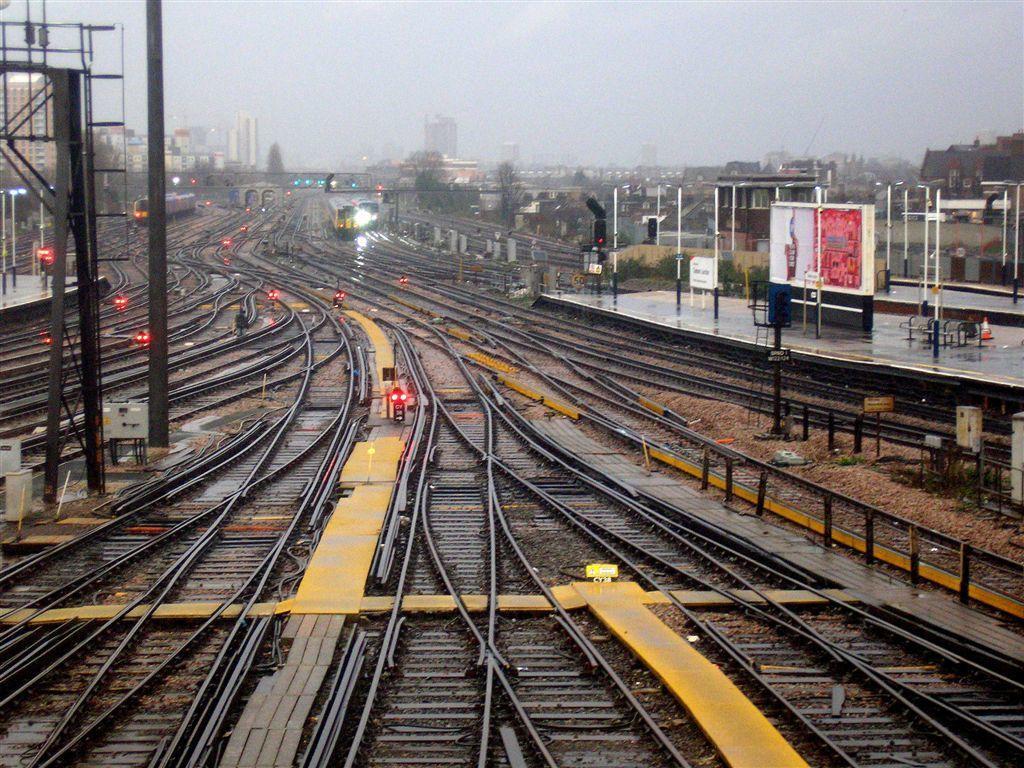Can you describe this image briefly? In this picture we can see the railway tracks, poles, rods, boards, lights, trains. In the center of the image we can see the buildings, trees. At the top of the image we can see the sky. On the right side of the image we can see the footpath and divider cone. 